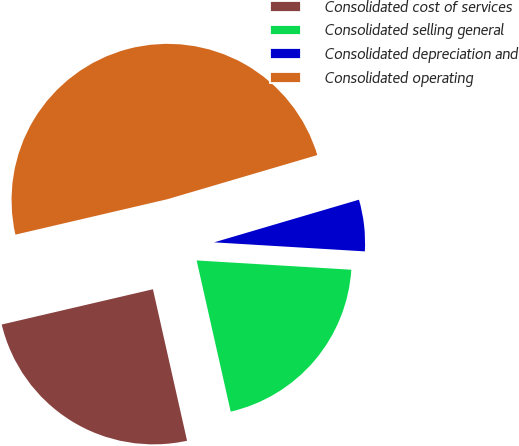Convert chart to OTSL. <chart><loc_0><loc_0><loc_500><loc_500><pie_chart><fcel>Consolidated cost of services<fcel>Consolidated selling general<fcel>Consolidated depreciation and<fcel>Consolidated operating<nl><fcel>24.88%<fcel>20.52%<fcel>5.51%<fcel>49.09%<nl></chart> 